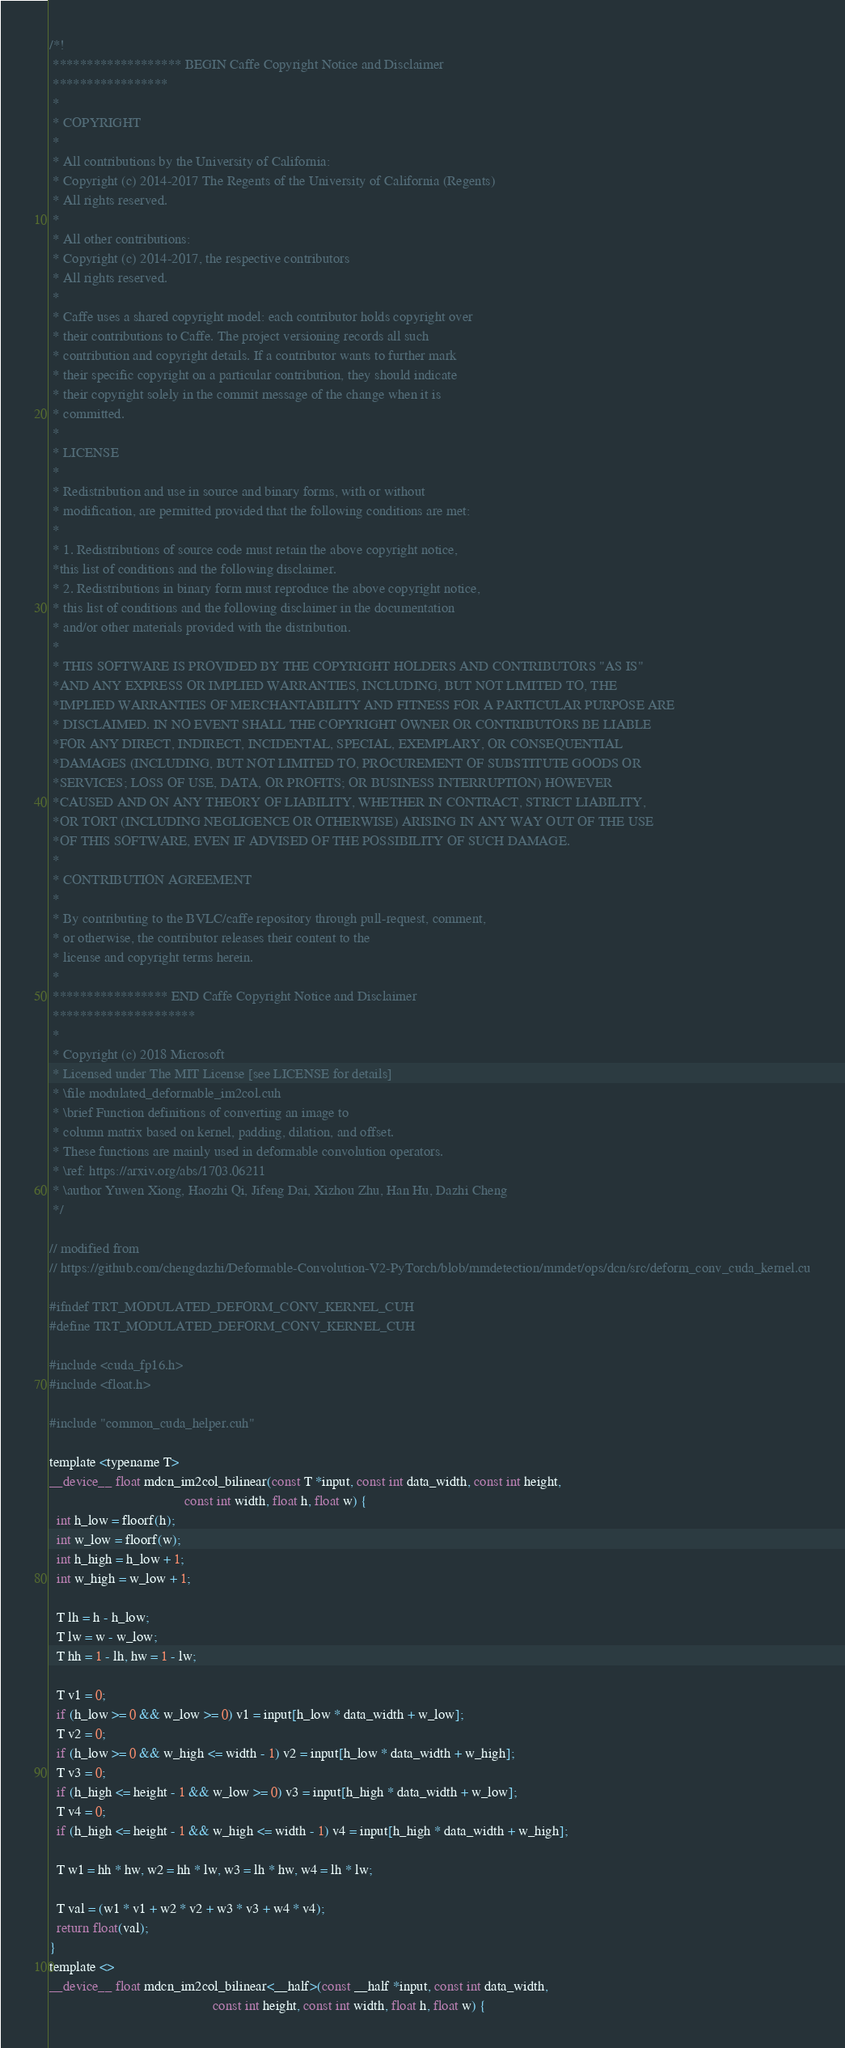Convert code to text. <code><loc_0><loc_0><loc_500><loc_500><_Cuda_>/*!
 ******************* BEGIN Caffe Copyright Notice and Disclaimer
 *****************
 *
 * COPYRIGHT
 *
 * All contributions by the University of California:
 * Copyright (c) 2014-2017 The Regents of the University of California (Regents)
 * All rights reserved.
 *
 * All other contributions:
 * Copyright (c) 2014-2017, the respective contributors
 * All rights reserved.
 *
 * Caffe uses a shared copyright model: each contributor holds copyright over
 * their contributions to Caffe. The project versioning records all such
 * contribution and copyright details. If a contributor wants to further mark
 * their specific copyright on a particular contribution, they should indicate
 * their copyright solely in the commit message of the change when it is
 * committed.
 *
 * LICENSE
 *
 * Redistribution and use in source and binary forms, with or without
 * modification, are permitted provided that the following conditions are met:
 *
 * 1. Redistributions of source code must retain the above copyright notice,
 *this list of conditions and the following disclaimer.
 * 2. Redistributions in binary form must reproduce the above copyright notice,
 * this list of conditions and the following disclaimer in the documentation
 * and/or other materials provided with the distribution.
 *
 * THIS SOFTWARE IS PROVIDED BY THE COPYRIGHT HOLDERS AND CONTRIBUTORS "AS IS"
 *AND ANY EXPRESS OR IMPLIED WARRANTIES, INCLUDING, BUT NOT LIMITED TO, THE
 *IMPLIED WARRANTIES OF MERCHANTABILITY AND FITNESS FOR A PARTICULAR PURPOSE ARE
 * DISCLAIMED. IN NO EVENT SHALL THE COPYRIGHT OWNER OR CONTRIBUTORS BE LIABLE
 *FOR ANY DIRECT, INDIRECT, INCIDENTAL, SPECIAL, EXEMPLARY, OR CONSEQUENTIAL
 *DAMAGES (INCLUDING, BUT NOT LIMITED TO, PROCUREMENT OF SUBSTITUTE GOODS OR
 *SERVICES; LOSS OF USE, DATA, OR PROFITS; OR BUSINESS INTERRUPTION) HOWEVER
 *CAUSED AND ON ANY THEORY OF LIABILITY, WHETHER IN CONTRACT, STRICT LIABILITY,
 *OR TORT (INCLUDING NEGLIGENCE OR OTHERWISE) ARISING IN ANY WAY OUT OF THE USE
 *OF THIS SOFTWARE, EVEN IF ADVISED OF THE POSSIBILITY OF SUCH DAMAGE.
 *
 * CONTRIBUTION AGREEMENT
 *
 * By contributing to the BVLC/caffe repository through pull-request, comment,
 * or otherwise, the contributor releases their content to the
 * license and copyright terms herein.
 *
 ***************** END Caffe Copyright Notice and Disclaimer
 *********************
 *
 * Copyright (c) 2018 Microsoft
 * Licensed under The MIT License [see LICENSE for details]
 * \file modulated_deformable_im2col.cuh
 * \brief Function definitions of converting an image to
 * column matrix based on kernel, padding, dilation, and offset.
 * These functions are mainly used in deformable convolution operators.
 * \ref: https://arxiv.org/abs/1703.06211
 * \author Yuwen Xiong, Haozhi Qi, Jifeng Dai, Xizhou Zhu, Han Hu, Dazhi Cheng
 */

// modified from
// https://github.com/chengdazhi/Deformable-Convolution-V2-PyTorch/blob/mmdetection/mmdet/ops/dcn/src/deform_conv_cuda_kernel.cu

#ifndef TRT_MODULATED_DEFORM_CONV_KERNEL_CUH
#define TRT_MODULATED_DEFORM_CONV_KERNEL_CUH

#include <cuda_fp16.h>
#include <float.h>

#include "common_cuda_helper.cuh"

template <typename T>
__device__ float mdcn_im2col_bilinear(const T *input, const int data_width, const int height,
                                      const int width, float h, float w) {
  int h_low = floorf(h);
  int w_low = floorf(w);
  int h_high = h_low + 1;
  int w_high = w_low + 1;

  T lh = h - h_low;
  T lw = w - w_low;
  T hh = 1 - lh, hw = 1 - lw;

  T v1 = 0;
  if (h_low >= 0 && w_low >= 0) v1 = input[h_low * data_width + w_low];
  T v2 = 0;
  if (h_low >= 0 && w_high <= width - 1) v2 = input[h_low * data_width + w_high];
  T v3 = 0;
  if (h_high <= height - 1 && w_low >= 0) v3 = input[h_high * data_width + w_low];
  T v4 = 0;
  if (h_high <= height - 1 && w_high <= width - 1) v4 = input[h_high * data_width + w_high];

  T w1 = hh * hw, w2 = hh * lw, w3 = lh * hw, w4 = lh * lw;

  T val = (w1 * v1 + w2 * v2 + w3 * v3 + w4 * v4);
  return float(val);
}
template <>
__device__ float mdcn_im2col_bilinear<__half>(const __half *input, const int data_width,
                                              const int height, const int width, float h, float w) {</code> 